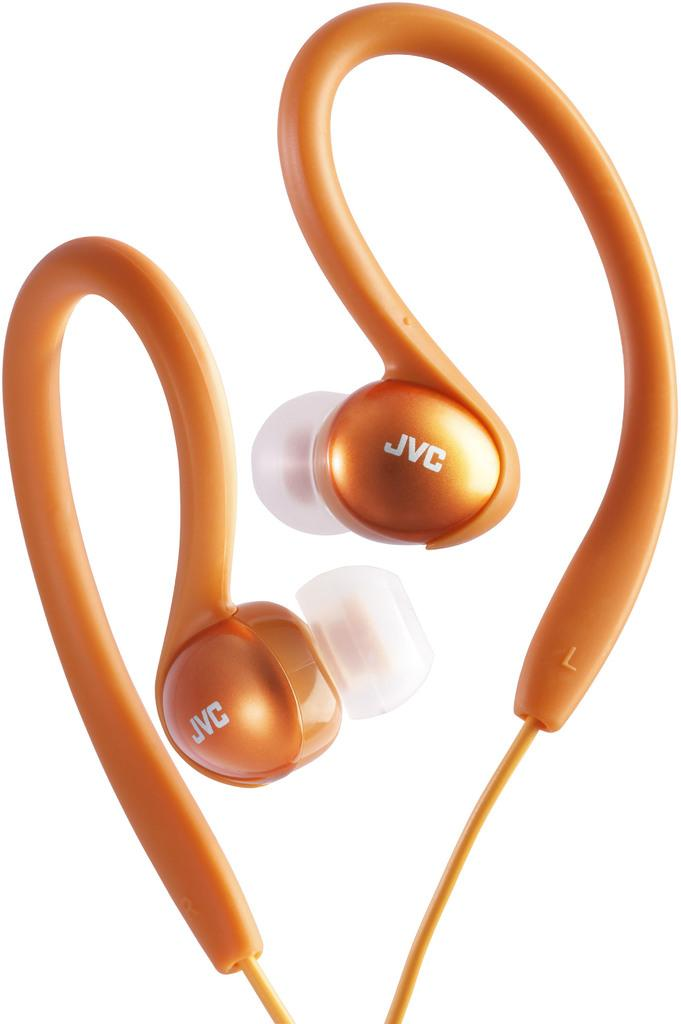<image>
Offer a succinct explanation of the picture presented. A pair of orange JVC ear buds against a white backdrop. 